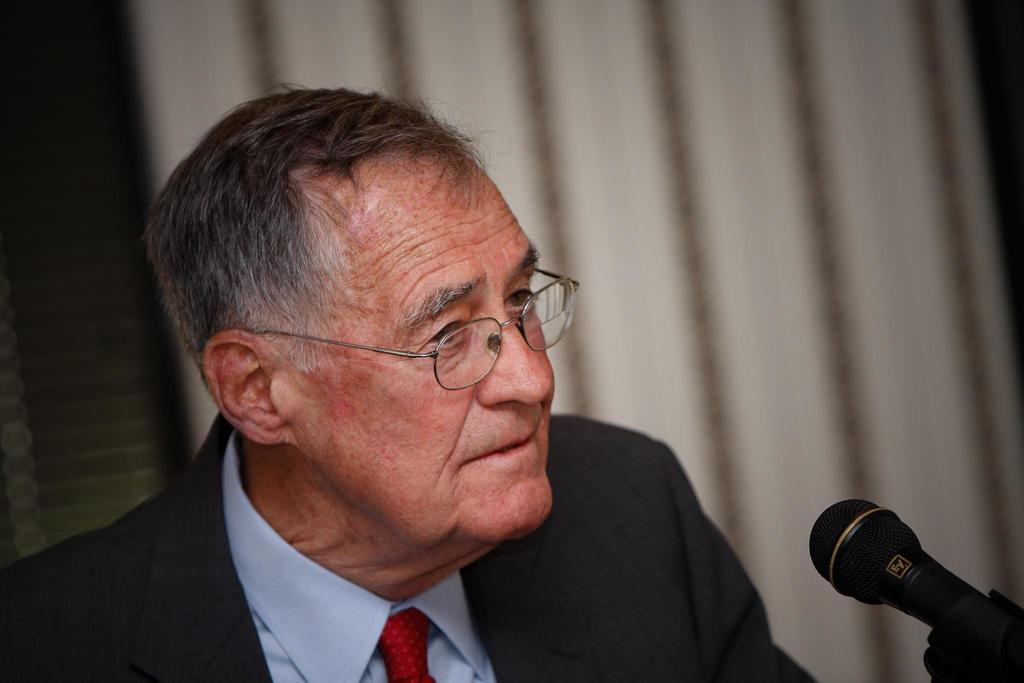Who is present in the image? There is a man in the image. What is the man wearing? The man is wearing a suit and a blue shirt. What object is in front of the man? There is a mic in front of the man. What can be seen in the background of the image? There is a curtain in the background of the image. What type of juice is being served at the man's birthday party in the image? There is no juice or birthday party present in the image; it features a man with a mic and a curtain in the background. 